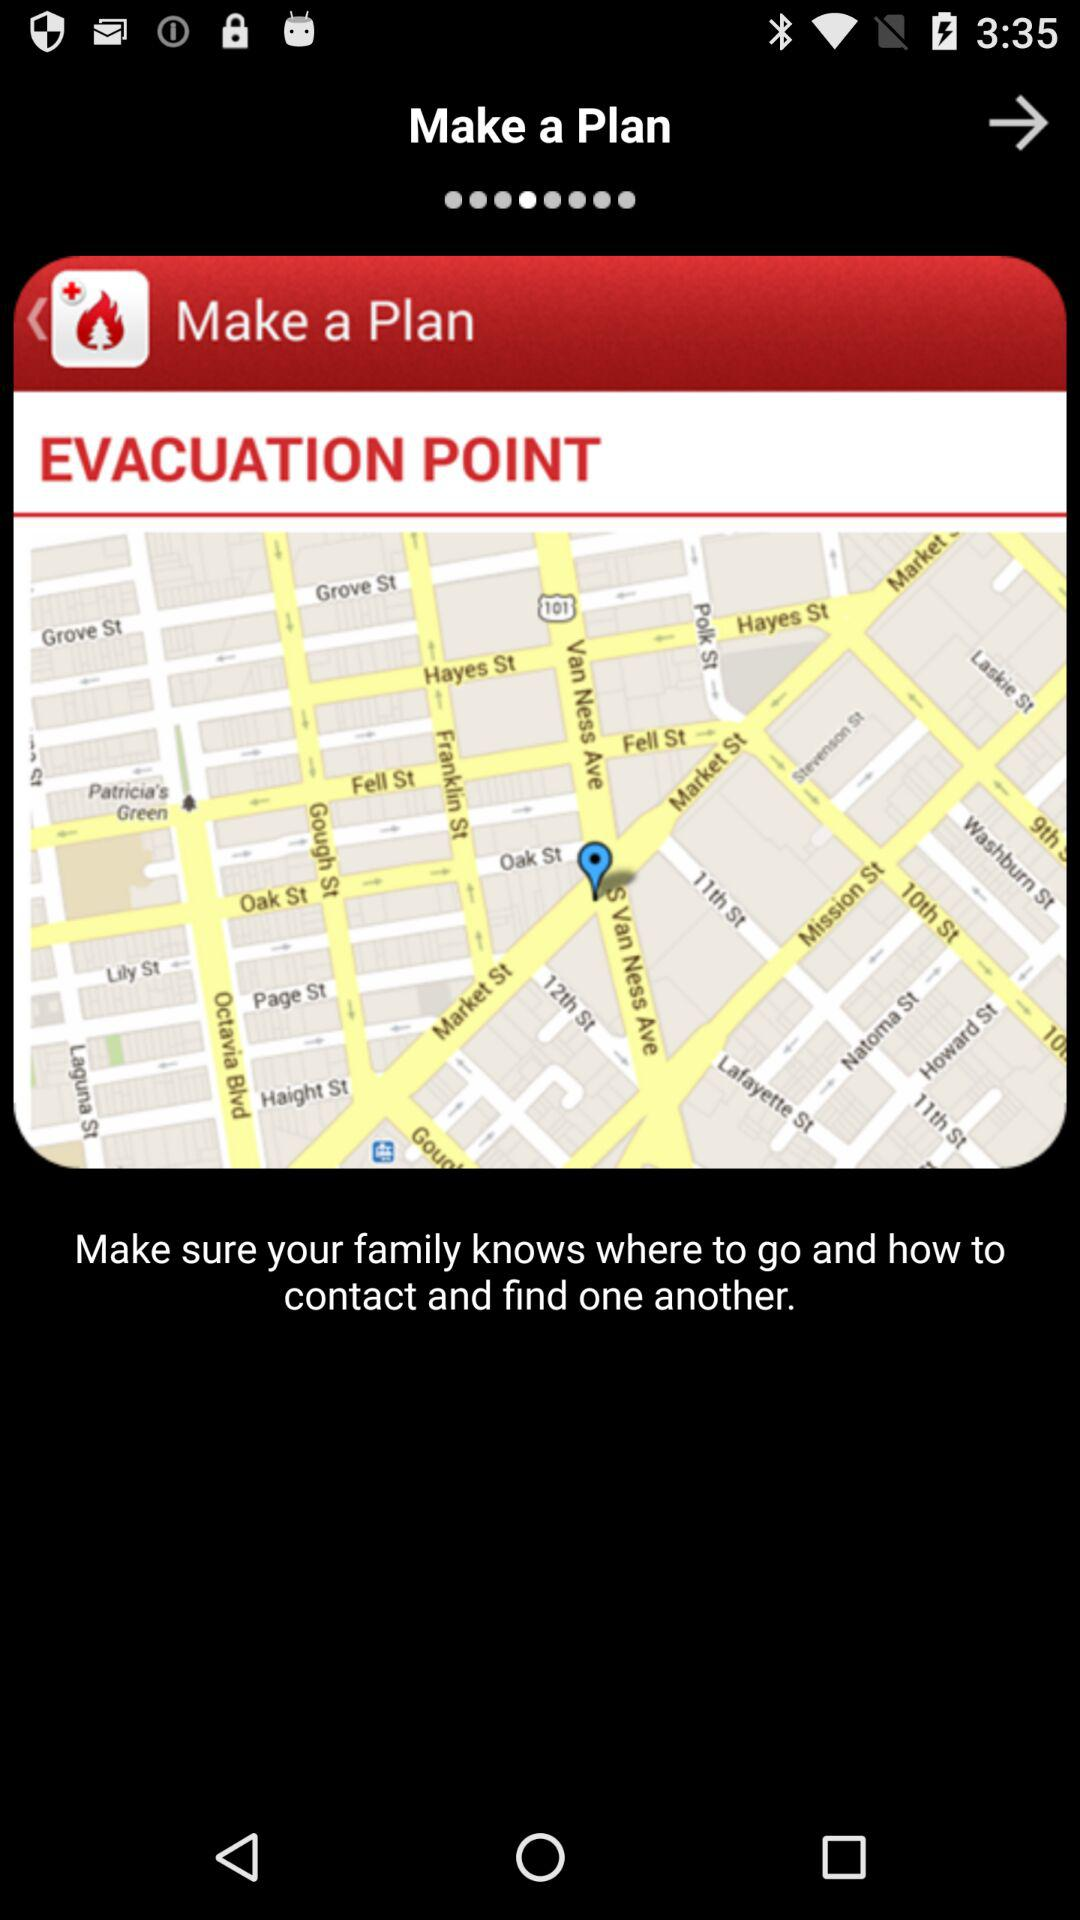What is the application name?
When the provided information is insufficient, respond with <no answer>. <no answer> 